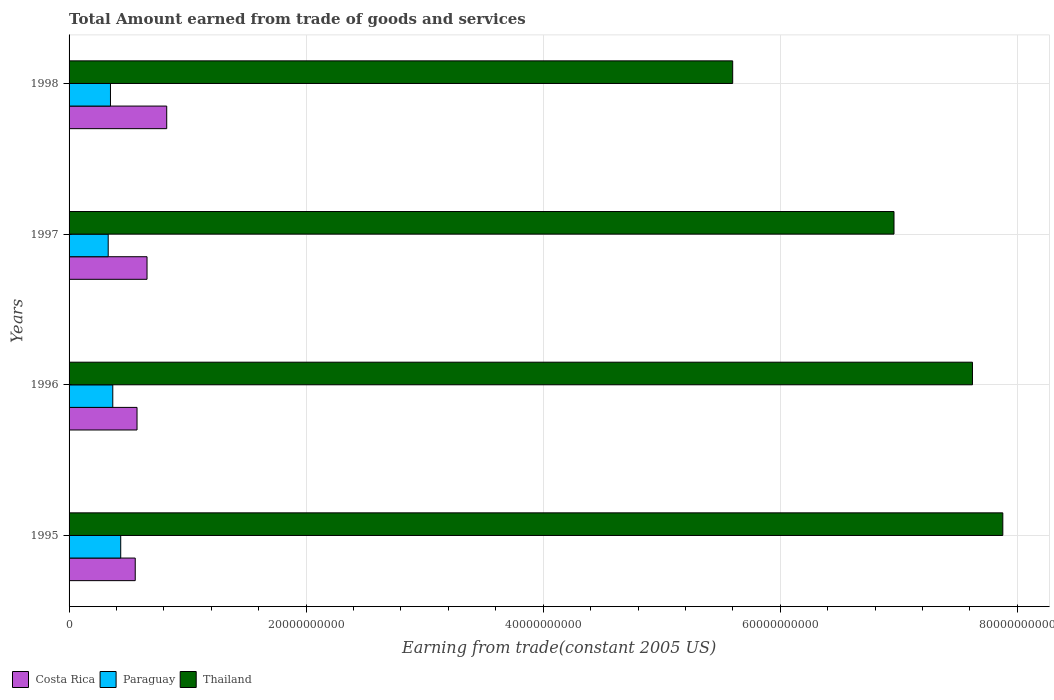Are the number of bars per tick equal to the number of legend labels?
Offer a terse response. Yes. Are the number of bars on each tick of the Y-axis equal?
Offer a terse response. Yes. How many bars are there on the 3rd tick from the top?
Offer a terse response. 3. How many bars are there on the 4th tick from the bottom?
Make the answer very short. 3. What is the label of the 3rd group of bars from the top?
Provide a short and direct response. 1996. In how many cases, is the number of bars for a given year not equal to the number of legend labels?
Your response must be concise. 0. What is the total amount earned by trading goods and services in Thailand in 1995?
Offer a very short reply. 7.88e+1. Across all years, what is the maximum total amount earned by trading goods and services in Thailand?
Offer a terse response. 7.88e+1. Across all years, what is the minimum total amount earned by trading goods and services in Costa Rica?
Ensure brevity in your answer.  5.58e+09. In which year was the total amount earned by trading goods and services in Paraguay minimum?
Offer a very short reply. 1997. What is the total total amount earned by trading goods and services in Costa Rica in the graph?
Provide a succinct answer. 2.61e+1. What is the difference between the total amount earned by trading goods and services in Costa Rica in 1997 and that in 1998?
Provide a succinct answer. -1.66e+09. What is the difference between the total amount earned by trading goods and services in Costa Rica in 1996 and the total amount earned by trading goods and services in Paraguay in 1998?
Keep it short and to the point. 2.24e+09. What is the average total amount earned by trading goods and services in Costa Rica per year?
Give a very brief answer. 6.53e+09. In the year 1997, what is the difference between the total amount earned by trading goods and services in Costa Rica and total amount earned by trading goods and services in Paraguay?
Ensure brevity in your answer.  3.28e+09. What is the ratio of the total amount earned by trading goods and services in Costa Rica in 1995 to that in 1997?
Provide a succinct answer. 0.85. Is the difference between the total amount earned by trading goods and services in Costa Rica in 1995 and 1996 greater than the difference between the total amount earned by trading goods and services in Paraguay in 1995 and 1996?
Give a very brief answer. No. What is the difference between the highest and the second highest total amount earned by trading goods and services in Paraguay?
Ensure brevity in your answer.  6.70e+08. What is the difference between the highest and the lowest total amount earned by trading goods and services in Paraguay?
Offer a very short reply. 1.06e+09. Is the sum of the total amount earned by trading goods and services in Thailand in 1996 and 1997 greater than the maximum total amount earned by trading goods and services in Costa Rica across all years?
Provide a short and direct response. Yes. What does the 1st bar from the top in 1997 represents?
Provide a succinct answer. Thailand. What does the 1st bar from the bottom in 1996 represents?
Your answer should be compact. Costa Rica. Is it the case that in every year, the sum of the total amount earned by trading goods and services in Costa Rica and total amount earned by trading goods and services in Paraguay is greater than the total amount earned by trading goods and services in Thailand?
Your answer should be very brief. No. How many years are there in the graph?
Keep it short and to the point. 4. What is the difference between two consecutive major ticks on the X-axis?
Your answer should be compact. 2.00e+1. Does the graph contain any zero values?
Provide a short and direct response. No. How are the legend labels stacked?
Offer a terse response. Horizontal. What is the title of the graph?
Provide a succinct answer. Total Amount earned from trade of goods and services. Does "Latvia" appear as one of the legend labels in the graph?
Ensure brevity in your answer.  No. What is the label or title of the X-axis?
Offer a very short reply. Earning from trade(constant 2005 US). What is the label or title of the Y-axis?
Your answer should be compact. Years. What is the Earning from trade(constant 2005 US) in Costa Rica in 1995?
Ensure brevity in your answer.  5.58e+09. What is the Earning from trade(constant 2005 US) of Paraguay in 1995?
Make the answer very short. 4.36e+09. What is the Earning from trade(constant 2005 US) in Thailand in 1995?
Offer a very short reply. 7.88e+1. What is the Earning from trade(constant 2005 US) of Costa Rica in 1996?
Keep it short and to the point. 5.73e+09. What is the Earning from trade(constant 2005 US) of Paraguay in 1996?
Provide a short and direct response. 3.69e+09. What is the Earning from trade(constant 2005 US) in Thailand in 1996?
Offer a terse response. 7.62e+1. What is the Earning from trade(constant 2005 US) of Costa Rica in 1997?
Offer a terse response. 6.58e+09. What is the Earning from trade(constant 2005 US) of Paraguay in 1997?
Your answer should be very brief. 3.30e+09. What is the Earning from trade(constant 2005 US) in Thailand in 1997?
Offer a very short reply. 6.96e+1. What is the Earning from trade(constant 2005 US) of Costa Rica in 1998?
Offer a terse response. 8.24e+09. What is the Earning from trade(constant 2005 US) of Paraguay in 1998?
Provide a succinct answer. 3.49e+09. What is the Earning from trade(constant 2005 US) of Thailand in 1998?
Offer a terse response. 5.60e+1. Across all years, what is the maximum Earning from trade(constant 2005 US) of Costa Rica?
Provide a succinct answer. 8.24e+09. Across all years, what is the maximum Earning from trade(constant 2005 US) of Paraguay?
Offer a very short reply. 4.36e+09. Across all years, what is the maximum Earning from trade(constant 2005 US) of Thailand?
Your response must be concise. 7.88e+1. Across all years, what is the minimum Earning from trade(constant 2005 US) of Costa Rica?
Make the answer very short. 5.58e+09. Across all years, what is the minimum Earning from trade(constant 2005 US) of Paraguay?
Your answer should be compact. 3.30e+09. Across all years, what is the minimum Earning from trade(constant 2005 US) of Thailand?
Offer a terse response. 5.60e+1. What is the total Earning from trade(constant 2005 US) of Costa Rica in the graph?
Offer a very short reply. 2.61e+1. What is the total Earning from trade(constant 2005 US) of Paraguay in the graph?
Make the answer very short. 1.48e+1. What is the total Earning from trade(constant 2005 US) of Thailand in the graph?
Your answer should be very brief. 2.81e+11. What is the difference between the Earning from trade(constant 2005 US) of Costa Rica in 1995 and that in 1996?
Your response must be concise. -1.51e+08. What is the difference between the Earning from trade(constant 2005 US) in Paraguay in 1995 and that in 1996?
Your answer should be compact. 6.70e+08. What is the difference between the Earning from trade(constant 2005 US) in Thailand in 1995 and that in 1996?
Provide a succinct answer. 2.56e+09. What is the difference between the Earning from trade(constant 2005 US) of Costa Rica in 1995 and that in 1997?
Your answer should be very brief. -9.96e+08. What is the difference between the Earning from trade(constant 2005 US) of Paraguay in 1995 and that in 1997?
Make the answer very short. 1.06e+09. What is the difference between the Earning from trade(constant 2005 US) of Thailand in 1995 and that in 1997?
Make the answer very short. 9.18e+09. What is the difference between the Earning from trade(constant 2005 US) in Costa Rica in 1995 and that in 1998?
Offer a terse response. -2.66e+09. What is the difference between the Earning from trade(constant 2005 US) in Paraguay in 1995 and that in 1998?
Give a very brief answer. 8.65e+08. What is the difference between the Earning from trade(constant 2005 US) in Thailand in 1995 and that in 1998?
Your response must be concise. 2.28e+1. What is the difference between the Earning from trade(constant 2005 US) in Costa Rica in 1996 and that in 1997?
Offer a terse response. -8.44e+08. What is the difference between the Earning from trade(constant 2005 US) in Paraguay in 1996 and that in 1997?
Provide a succinct answer. 3.85e+08. What is the difference between the Earning from trade(constant 2005 US) in Thailand in 1996 and that in 1997?
Your response must be concise. 6.62e+09. What is the difference between the Earning from trade(constant 2005 US) in Costa Rica in 1996 and that in 1998?
Ensure brevity in your answer.  -2.50e+09. What is the difference between the Earning from trade(constant 2005 US) of Paraguay in 1996 and that in 1998?
Offer a terse response. 1.95e+08. What is the difference between the Earning from trade(constant 2005 US) of Thailand in 1996 and that in 1998?
Your answer should be compact. 2.02e+1. What is the difference between the Earning from trade(constant 2005 US) in Costa Rica in 1997 and that in 1998?
Make the answer very short. -1.66e+09. What is the difference between the Earning from trade(constant 2005 US) of Paraguay in 1997 and that in 1998?
Your answer should be compact. -1.90e+08. What is the difference between the Earning from trade(constant 2005 US) of Thailand in 1997 and that in 1998?
Offer a very short reply. 1.36e+1. What is the difference between the Earning from trade(constant 2005 US) in Costa Rica in 1995 and the Earning from trade(constant 2005 US) in Paraguay in 1996?
Provide a succinct answer. 1.89e+09. What is the difference between the Earning from trade(constant 2005 US) in Costa Rica in 1995 and the Earning from trade(constant 2005 US) in Thailand in 1996?
Make the answer very short. -7.06e+1. What is the difference between the Earning from trade(constant 2005 US) of Paraguay in 1995 and the Earning from trade(constant 2005 US) of Thailand in 1996?
Offer a terse response. -7.19e+1. What is the difference between the Earning from trade(constant 2005 US) of Costa Rica in 1995 and the Earning from trade(constant 2005 US) of Paraguay in 1997?
Offer a very short reply. 2.28e+09. What is the difference between the Earning from trade(constant 2005 US) in Costa Rica in 1995 and the Earning from trade(constant 2005 US) in Thailand in 1997?
Your answer should be compact. -6.40e+1. What is the difference between the Earning from trade(constant 2005 US) in Paraguay in 1995 and the Earning from trade(constant 2005 US) in Thailand in 1997?
Offer a very short reply. -6.52e+1. What is the difference between the Earning from trade(constant 2005 US) of Costa Rica in 1995 and the Earning from trade(constant 2005 US) of Paraguay in 1998?
Give a very brief answer. 2.09e+09. What is the difference between the Earning from trade(constant 2005 US) of Costa Rica in 1995 and the Earning from trade(constant 2005 US) of Thailand in 1998?
Keep it short and to the point. -5.04e+1. What is the difference between the Earning from trade(constant 2005 US) in Paraguay in 1995 and the Earning from trade(constant 2005 US) in Thailand in 1998?
Ensure brevity in your answer.  -5.16e+1. What is the difference between the Earning from trade(constant 2005 US) in Costa Rica in 1996 and the Earning from trade(constant 2005 US) in Paraguay in 1997?
Your answer should be compact. 2.43e+09. What is the difference between the Earning from trade(constant 2005 US) in Costa Rica in 1996 and the Earning from trade(constant 2005 US) in Thailand in 1997?
Make the answer very short. -6.39e+1. What is the difference between the Earning from trade(constant 2005 US) in Paraguay in 1996 and the Earning from trade(constant 2005 US) in Thailand in 1997?
Offer a terse response. -6.59e+1. What is the difference between the Earning from trade(constant 2005 US) of Costa Rica in 1996 and the Earning from trade(constant 2005 US) of Paraguay in 1998?
Keep it short and to the point. 2.24e+09. What is the difference between the Earning from trade(constant 2005 US) in Costa Rica in 1996 and the Earning from trade(constant 2005 US) in Thailand in 1998?
Give a very brief answer. -5.03e+1. What is the difference between the Earning from trade(constant 2005 US) of Paraguay in 1996 and the Earning from trade(constant 2005 US) of Thailand in 1998?
Your answer should be very brief. -5.23e+1. What is the difference between the Earning from trade(constant 2005 US) of Costa Rica in 1997 and the Earning from trade(constant 2005 US) of Paraguay in 1998?
Ensure brevity in your answer.  3.08e+09. What is the difference between the Earning from trade(constant 2005 US) in Costa Rica in 1997 and the Earning from trade(constant 2005 US) in Thailand in 1998?
Your answer should be compact. -4.94e+1. What is the difference between the Earning from trade(constant 2005 US) of Paraguay in 1997 and the Earning from trade(constant 2005 US) of Thailand in 1998?
Offer a terse response. -5.27e+1. What is the average Earning from trade(constant 2005 US) in Costa Rica per year?
Your response must be concise. 6.53e+09. What is the average Earning from trade(constant 2005 US) in Paraguay per year?
Ensure brevity in your answer.  3.71e+09. What is the average Earning from trade(constant 2005 US) in Thailand per year?
Your answer should be compact. 7.01e+1. In the year 1995, what is the difference between the Earning from trade(constant 2005 US) of Costa Rica and Earning from trade(constant 2005 US) of Paraguay?
Your answer should be compact. 1.22e+09. In the year 1995, what is the difference between the Earning from trade(constant 2005 US) of Costa Rica and Earning from trade(constant 2005 US) of Thailand?
Provide a succinct answer. -7.32e+1. In the year 1995, what is the difference between the Earning from trade(constant 2005 US) in Paraguay and Earning from trade(constant 2005 US) in Thailand?
Offer a very short reply. -7.44e+1. In the year 1996, what is the difference between the Earning from trade(constant 2005 US) of Costa Rica and Earning from trade(constant 2005 US) of Paraguay?
Make the answer very short. 2.05e+09. In the year 1996, what is the difference between the Earning from trade(constant 2005 US) of Costa Rica and Earning from trade(constant 2005 US) of Thailand?
Give a very brief answer. -7.05e+1. In the year 1996, what is the difference between the Earning from trade(constant 2005 US) in Paraguay and Earning from trade(constant 2005 US) in Thailand?
Make the answer very short. -7.25e+1. In the year 1997, what is the difference between the Earning from trade(constant 2005 US) of Costa Rica and Earning from trade(constant 2005 US) of Paraguay?
Offer a terse response. 3.28e+09. In the year 1997, what is the difference between the Earning from trade(constant 2005 US) of Costa Rica and Earning from trade(constant 2005 US) of Thailand?
Ensure brevity in your answer.  -6.30e+1. In the year 1997, what is the difference between the Earning from trade(constant 2005 US) of Paraguay and Earning from trade(constant 2005 US) of Thailand?
Make the answer very short. -6.63e+1. In the year 1998, what is the difference between the Earning from trade(constant 2005 US) in Costa Rica and Earning from trade(constant 2005 US) in Paraguay?
Your response must be concise. 4.75e+09. In the year 1998, what is the difference between the Earning from trade(constant 2005 US) in Costa Rica and Earning from trade(constant 2005 US) in Thailand?
Your answer should be compact. -4.77e+1. In the year 1998, what is the difference between the Earning from trade(constant 2005 US) in Paraguay and Earning from trade(constant 2005 US) in Thailand?
Ensure brevity in your answer.  -5.25e+1. What is the ratio of the Earning from trade(constant 2005 US) in Costa Rica in 1995 to that in 1996?
Provide a short and direct response. 0.97. What is the ratio of the Earning from trade(constant 2005 US) in Paraguay in 1995 to that in 1996?
Your answer should be compact. 1.18. What is the ratio of the Earning from trade(constant 2005 US) in Thailand in 1995 to that in 1996?
Ensure brevity in your answer.  1.03. What is the ratio of the Earning from trade(constant 2005 US) of Costa Rica in 1995 to that in 1997?
Your response must be concise. 0.85. What is the ratio of the Earning from trade(constant 2005 US) in Paraguay in 1995 to that in 1997?
Your response must be concise. 1.32. What is the ratio of the Earning from trade(constant 2005 US) of Thailand in 1995 to that in 1997?
Offer a very short reply. 1.13. What is the ratio of the Earning from trade(constant 2005 US) in Costa Rica in 1995 to that in 1998?
Provide a short and direct response. 0.68. What is the ratio of the Earning from trade(constant 2005 US) in Paraguay in 1995 to that in 1998?
Your response must be concise. 1.25. What is the ratio of the Earning from trade(constant 2005 US) in Thailand in 1995 to that in 1998?
Offer a very short reply. 1.41. What is the ratio of the Earning from trade(constant 2005 US) of Costa Rica in 1996 to that in 1997?
Provide a succinct answer. 0.87. What is the ratio of the Earning from trade(constant 2005 US) of Paraguay in 1996 to that in 1997?
Offer a terse response. 1.12. What is the ratio of the Earning from trade(constant 2005 US) of Thailand in 1996 to that in 1997?
Your answer should be very brief. 1.1. What is the ratio of the Earning from trade(constant 2005 US) of Costa Rica in 1996 to that in 1998?
Keep it short and to the point. 0.7. What is the ratio of the Earning from trade(constant 2005 US) in Paraguay in 1996 to that in 1998?
Provide a short and direct response. 1.06. What is the ratio of the Earning from trade(constant 2005 US) in Thailand in 1996 to that in 1998?
Make the answer very short. 1.36. What is the ratio of the Earning from trade(constant 2005 US) of Costa Rica in 1997 to that in 1998?
Offer a very short reply. 0.8. What is the ratio of the Earning from trade(constant 2005 US) of Paraguay in 1997 to that in 1998?
Your answer should be very brief. 0.95. What is the ratio of the Earning from trade(constant 2005 US) in Thailand in 1997 to that in 1998?
Offer a terse response. 1.24. What is the difference between the highest and the second highest Earning from trade(constant 2005 US) in Costa Rica?
Ensure brevity in your answer.  1.66e+09. What is the difference between the highest and the second highest Earning from trade(constant 2005 US) in Paraguay?
Ensure brevity in your answer.  6.70e+08. What is the difference between the highest and the second highest Earning from trade(constant 2005 US) of Thailand?
Offer a very short reply. 2.56e+09. What is the difference between the highest and the lowest Earning from trade(constant 2005 US) of Costa Rica?
Offer a very short reply. 2.66e+09. What is the difference between the highest and the lowest Earning from trade(constant 2005 US) of Paraguay?
Your response must be concise. 1.06e+09. What is the difference between the highest and the lowest Earning from trade(constant 2005 US) of Thailand?
Keep it short and to the point. 2.28e+1. 